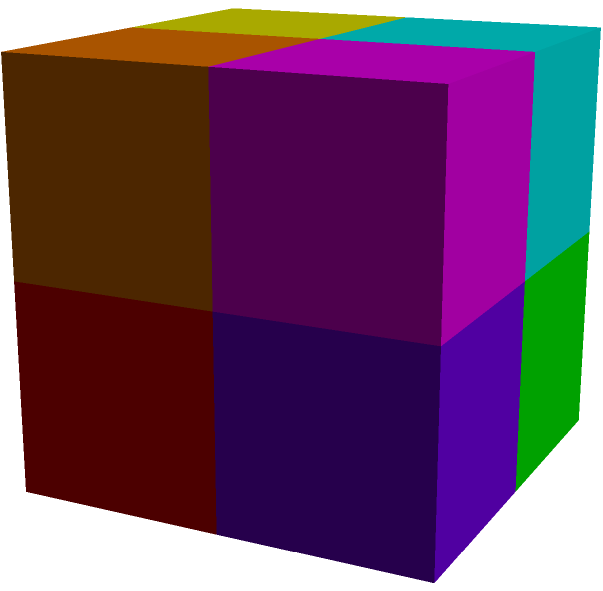Count the total number of visible faces in the complex 3D structure shown above, which is composed of 8 unit cubes arranged in a 2x2x2 configuration. Each cube has a different color for easier identification. To count the visible faces, let's approach this systematically:

1. First, consider the outer faces of the entire structure:
   - Front face: 4 visible cube faces
   - Right face: 4 visible cube faces
   - Top face: 4 visible cube faces

2. Now, let's count the visible inner faces:
   - Between the front and back layer: 4 visible cube faces
   - Between the left and right layer: 4 visible cube faces
   - Between the top and bottom layer: 4 visible cube faces

3. Sum up all visible faces:
   - Outer faces: $4 + 4 + 4 = 12$
   - Inner faces: $4 + 4 + 4 = 12$
   - Total: $12 + 12 = 24$

Therefore, the total number of visible faces in this 3D structure is 24.
Answer: 24 